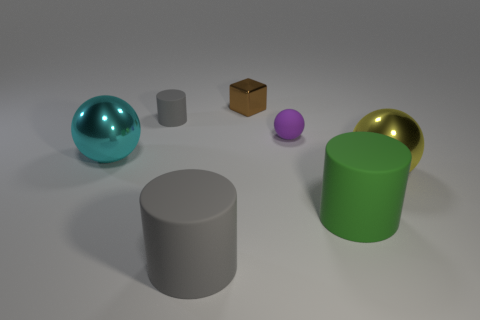There is a big shiny thing that is right of the cyan metal object; is it the same color as the large matte cylinder that is to the left of the shiny block?
Your response must be concise. No. Are there more tiny cylinders than tiny rubber objects?
Your answer should be compact. No. What number of metal spheres are the same color as the shiny block?
Provide a succinct answer. 0. What color is the other big shiny object that is the same shape as the yellow metallic object?
Make the answer very short. Cyan. There is a object that is in front of the big yellow sphere and on the right side of the small ball; what is its material?
Your response must be concise. Rubber. Does the tiny purple ball behind the big green object have the same material as the sphere that is to the left of the big gray matte cylinder?
Your response must be concise. No. How big is the yellow metallic sphere?
Give a very brief answer. Large. The green rubber object that is the same shape as the big gray rubber object is what size?
Your response must be concise. Large. How many yellow metal balls are behind the large yellow object?
Your response must be concise. 0. What is the color of the big object right of the cylinder right of the tiny metal thing?
Keep it short and to the point. Yellow. 